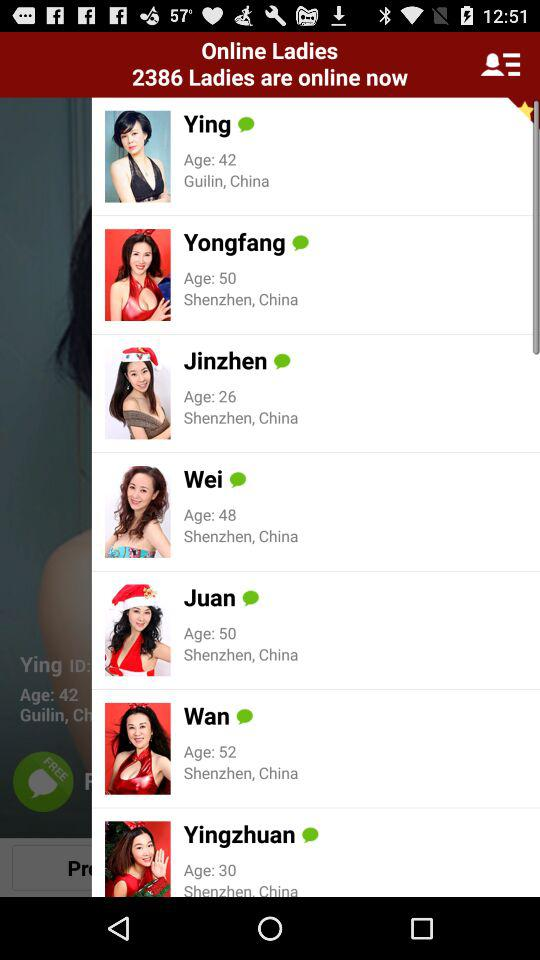How many unread messages are there?
When the provided information is insufficient, respond with <no answer>. <no answer> 